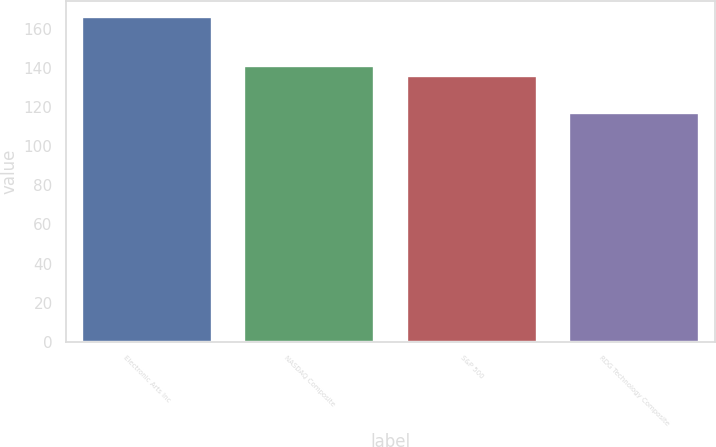<chart> <loc_0><loc_0><loc_500><loc_500><bar_chart><fcel>Electronic Arts Inc<fcel>NASDAQ Composite<fcel>S&P 500<fcel>RDG Technology Composite<nl><fcel>166<fcel>140.9<fcel>136<fcel>117<nl></chart> 